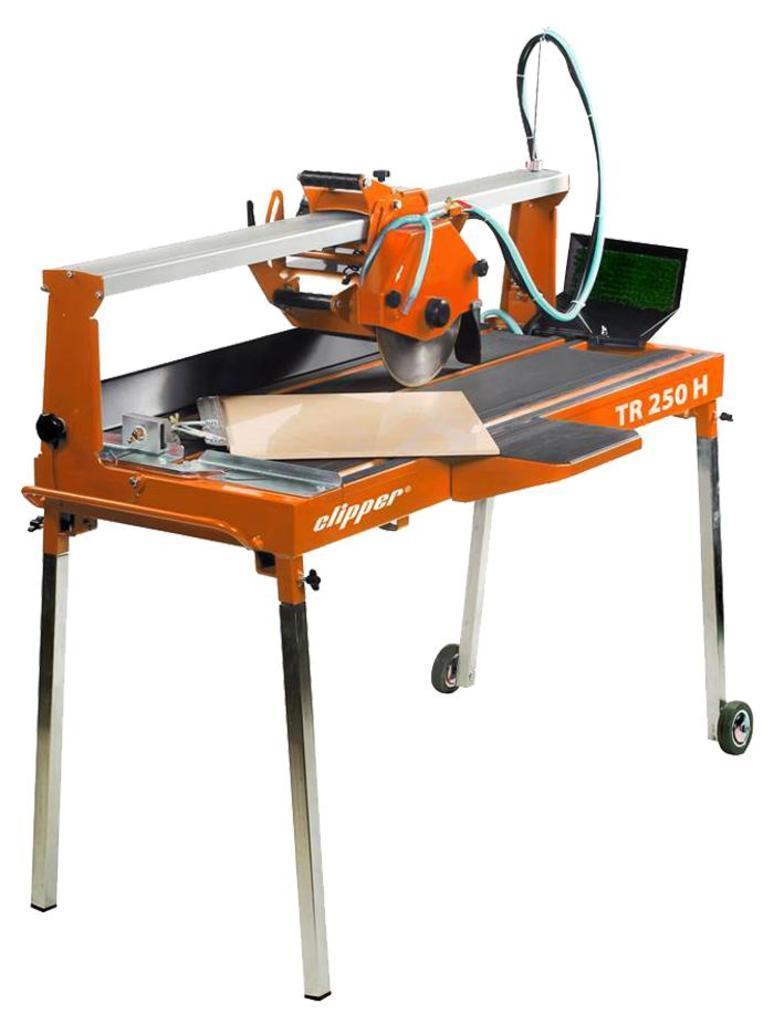Could you give a brief overview of what you see in this image? In this image I can see the machine which is in orange, grey, green and white color. And there is a white background. 